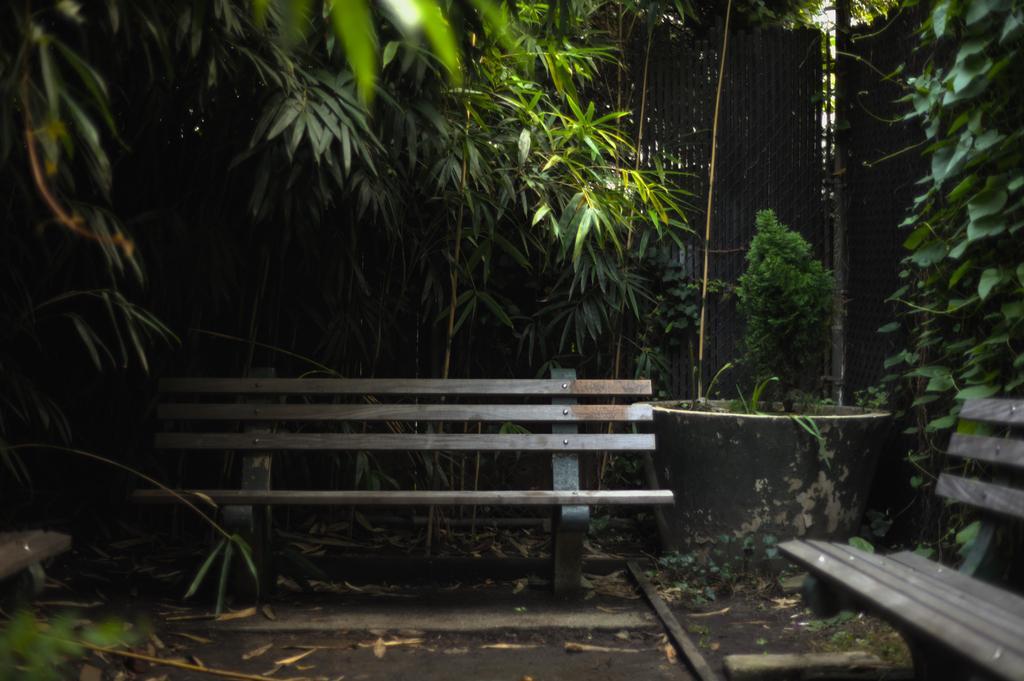How would you summarize this image in a sentence or two? In this image I can see ground, two benches on the ground, a flower pot and a tree which is green in color in it. In the background I can see few trees which are green in color and the fencing. 